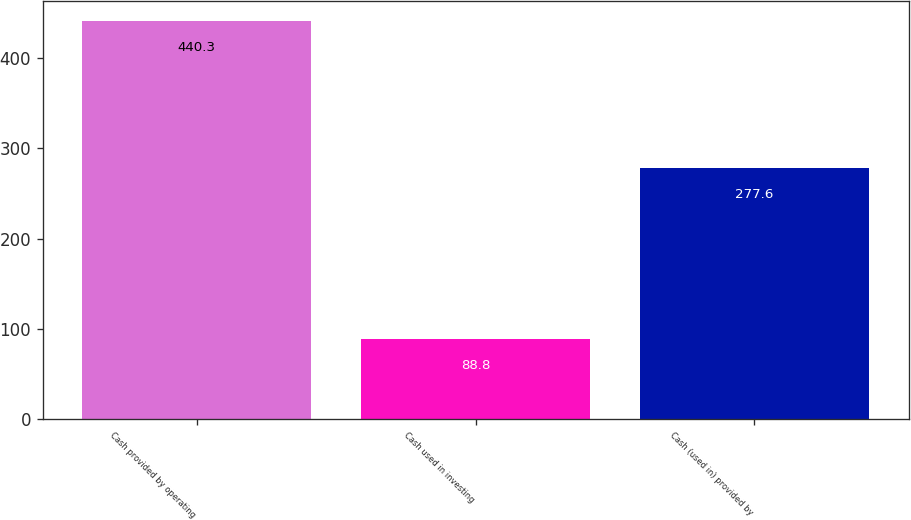Convert chart. <chart><loc_0><loc_0><loc_500><loc_500><bar_chart><fcel>Cash provided by operating<fcel>Cash used in investing<fcel>Cash (used in) provided by<nl><fcel>440.3<fcel>88.8<fcel>277.6<nl></chart> 